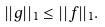<formula> <loc_0><loc_0><loc_500><loc_500>| | g | | _ { 1 } \leq | | f | | _ { 1 } .</formula> 